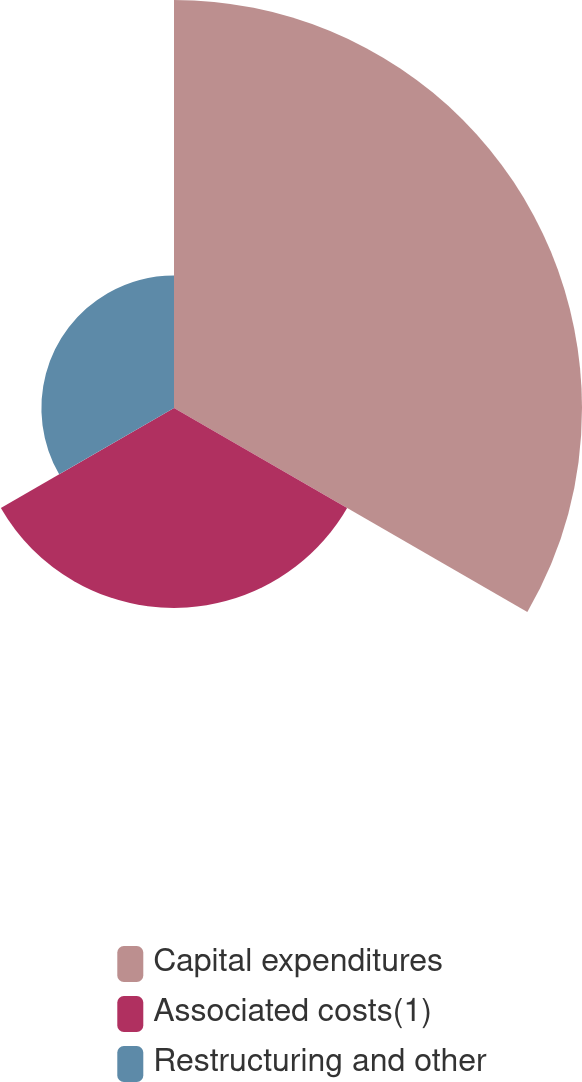Convert chart to OTSL. <chart><loc_0><loc_0><loc_500><loc_500><pie_chart><fcel>Capital expenditures<fcel>Associated costs(1)<fcel>Restructuring and other<nl><fcel>55.1%<fcel>27.0%<fcel>17.91%<nl></chart> 